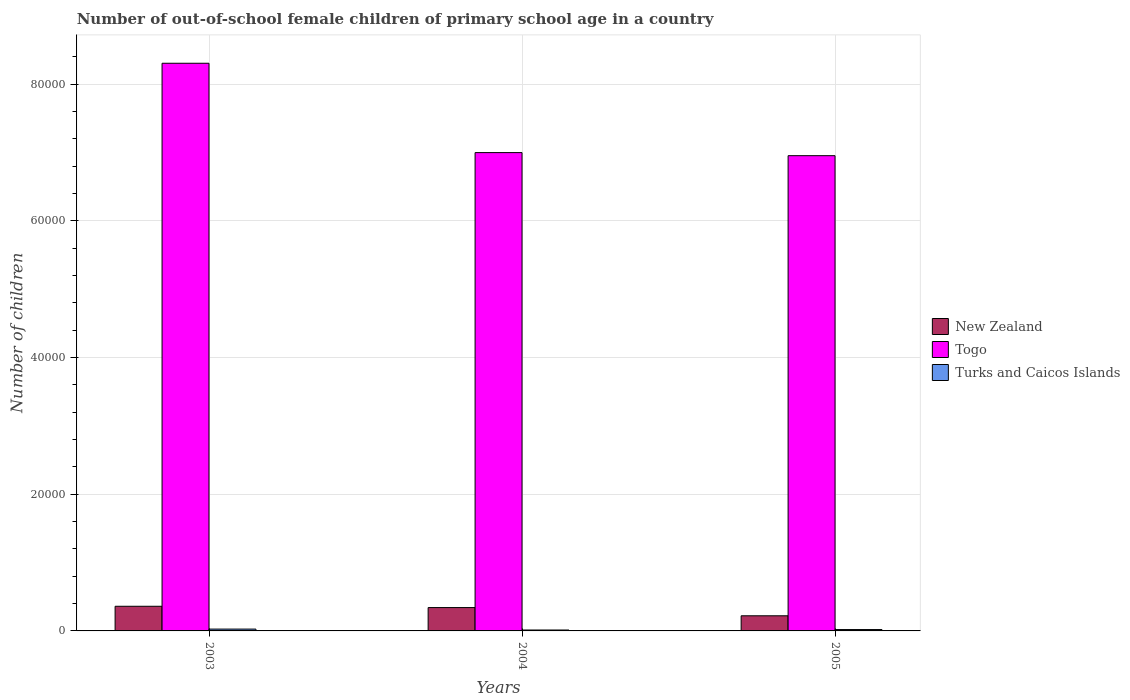How many bars are there on the 3rd tick from the right?
Your answer should be very brief. 3. What is the label of the 3rd group of bars from the left?
Offer a very short reply. 2005. What is the number of out-of-school female children in New Zealand in 2004?
Your answer should be very brief. 3417. Across all years, what is the maximum number of out-of-school female children in Turks and Caicos Islands?
Give a very brief answer. 268. Across all years, what is the minimum number of out-of-school female children in Turks and Caicos Islands?
Keep it short and to the point. 134. In which year was the number of out-of-school female children in Togo maximum?
Ensure brevity in your answer.  2003. What is the total number of out-of-school female children in Turks and Caicos Islands in the graph?
Your response must be concise. 601. What is the difference between the number of out-of-school female children in New Zealand in 2003 and that in 2005?
Make the answer very short. 1393. What is the difference between the number of out-of-school female children in Turks and Caicos Islands in 2005 and the number of out-of-school female children in Togo in 2004?
Your answer should be compact. -6.98e+04. What is the average number of out-of-school female children in Togo per year?
Ensure brevity in your answer.  7.42e+04. In the year 2004, what is the difference between the number of out-of-school female children in New Zealand and number of out-of-school female children in Turks and Caicos Islands?
Ensure brevity in your answer.  3283. What is the ratio of the number of out-of-school female children in New Zealand in 2003 to that in 2005?
Offer a very short reply. 1.63. What is the difference between the highest and the second highest number of out-of-school female children in Togo?
Offer a very short reply. 1.31e+04. What is the difference between the highest and the lowest number of out-of-school female children in New Zealand?
Ensure brevity in your answer.  1393. Is the sum of the number of out-of-school female children in New Zealand in 2004 and 2005 greater than the maximum number of out-of-school female children in Togo across all years?
Provide a short and direct response. No. What does the 3rd bar from the left in 2004 represents?
Your answer should be very brief. Turks and Caicos Islands. What does the 1st bar from the right in 2004 represents?
Offer a very short reply. Turks and Caicos Islands. Is it the case that in every year, the sum of the number of out-of-school female children in Turks and Caicos Islands and number of out-of-school female children in New Zealand is greater than the number of out-of-school female children in Togo?
Give a very brief answer. No. Are the values on the major ticks of Y-axis written in scientific E-notation?
Your response must be concise. No. How many legend labels are there?
Your answer should be compact. 3. How are the legend labels stacked?
Offer a terse response. Vertical. What is the title of the graph?
Keep it short and to the point. Number of out-of-school female children of primary school age in a country. What is the label or title of the X-axis?
Make the answer very short. Years. What is the label or title of the Y-axis?
Provide a short and direct response. Number of children. What is the Number of children in New Zealand in 2003?
Offer a terse response. 3607. What is the Number of children in Togo in 2003?
Keep it short and to the point. 8.31e+04. What is the Number of children of Turks and Caicos Islands in 2003?
Give a very brief answer. 268. What is the Number of children in New Zealand in 2004?
Keep it short and to the point. 3417. What is the Number of children of Togo in 2004?
Your response must be concise. 7.00e+04. What is the Number of children in Turks and Caicos Islands in 2004?
Your response must be concise. 134. What is the Number of children in New Zealand in 2005?
Your answer should be compact. 2214. What is the Number of children of Togo in 2005?
Your answer should be very brief. 6.95e+04. What is the Number of children in Turks and Caicos Islands in 2005?
Your response must be concise. 199. Across all years, what is the maximum Number of children of New Zealand?
Your response must be concise. 3607. Across all years, what is the maximum Number of children in Togo?
Provide a succinct answer. 8.31e+04. Across all years, what is the maximum Number of children in Turks and Caicos Islands?
Provide a short and direct response. 268. Across all years, what is the minimum Number of children in New Zealand?
Provide a short and direct response. 2214. Across all years, what is the minimum Number of children of Togo?
Keep it short and to the point. 6.95e+04. Across all years, what is the minimum Number of children in Turks and Caicos Islands?
Your response must be concise. 134. What is the total Number of children of New Zealand in the graph?
Give a very brief answer. 9238. What is the total Number of children of Togo in the graph?
Provide a succinct answer. 2.23e+05. What is the total Number of children in Turks and Caicos Islands in the graph?
Make the answer very short. 601. What is the difference between the Number of children in New Zealand in 2003 and that in 2004?
Your response must be concise. 190. What is the difference between the Number of children of Togo in 2003 and that in 2004?
Give a very brief answer. 1.31e+04. What is the difference between the Number of children in Turks and Caicos Islands in 2003 and that in 2004?
Give a very brief answer. 134. What is the difference between the Number of children in New Zealand in 2003 and that in 2005?
Offer a terse response. 1393. What is the difference between the Number of children of Togo in 2003 and that in 2005?
Provide a short and direct response. 1.35e+04. What is the difference between the Number of children of New Zealand in 2004 and that in 2005?
Give a very brief answer. 1203. What is the difference between the Number of children of Togo in 2004 and that in 2005?
Offer a terse response. 450. What is the difference between the Number of children of Turks and Caicos Islands in 2004 and that in 2005?
Your answer should be very brief. -65. What is the difference between the Number of children of New Zealand in 2003 and the Number of children of Togo in 2004?
Your answer should be very brief. -6.64e+04. What is the difference between the Number of children in New Zealand in 2003 and the Number of children in Turks and Caicos Islands in 2004?
Your answer should be compact. 3473. What is the difference between the Number of children in Togo in 2003 and the Number of children in Turks and Caicos Islands in 2004?
Keep it short and to the point. 8.29e+04. What is the difference between the Number of children in New Zealand in 2003 and the Number of children in Togo in 2005?
Offer a very short reply. -6.59e+04. What is the difference between the Number of children of New Zealand in 2003 and the Number of children of Turks and Caicos Islands in 2005?
Your answer should be very brief. 3408. What is the difference between the Number of children in Togo in 2003 and the Number of children in Turks and Caicos Islands in 2005?
Your answer should be compact. 8.29e+04. What is the difference between the Number of children of New Zealand in 2004 and the Number of children of Togo in 2005?
Provide a short and direct response. -6.61e+04. What is the difference between the Number of children in New Zealand in 2004 and the Number of children in Turks and Caicos Islands in 2005?
Give a very brief answer. 3218. What is the difference between the Number of children of Togo in 2004 and the Number of children of Turks and Caicos Islands in 2005?
Your answer should be very brief. 6.98e+04. What is the average Number of children of New Zealand per year?
Your answer should be very brief. 3079.33. What is the average Number of children of Togo per year?
Make the answer very short. 7.42e+04. What is the average Number of children of Turks and Caicos Islands per year?
Offer a terse response. 200.33. In the year 2003, what is the difference between the Number of children in New Zealand and Number of children in Togo?
Ensure brevity in your answer.  -7.95e+04. In the year 2003, what is the difference between the Number of children of New Zealand and Number of children of Turks and Caicos Islands?
Keep it short and to the point. 3339. In the year 2003, what is the difference between the Number of children in Togo and Number of children in Turks and Caicos Islands?
Your answer should be very brief. 8.28e+04. In the year 2004, what is the difference between the Number of children in New Zealand and Number of children in Togo?
Give a very brief answer. -6.66e+04. In the year 2004, what is the difference between the Number of children of New Zealand and Number of children of Turks and Caicos Islands?
Your answer should be very brief. 3283. In the year 2004, what is the difference between the Number of children of Togo and Number of children of Turks and Caicos Islands?
Offer a terse response. 6.99e+04. In the year 2005, what is the difference between the Number of children in New Zealand and Number of children in Togo?
Your answer should be very brief. -6.73e+04. In the year 2005, what is the difference between the Number of children in New Zealand and Number of children in Turks and Caicos Islands?
Provide a short and direct response. 2015. In the year 2005, what is the difference between the Number of children of Togo and Number of children of Turks and Caicos Islands?
Your response must be concise. 6.93e+04. What is the ratio of the Number of children in New Zealand in 2003 to that in 2004?
Ensure brevity in your answer.  1.06. What is the ratio of the Number of children in Togo in 2003 to that in 2004?
Your answer should be compact. 1.19. What is the ratio of the Number of children of New Zealand in 2003 to that in 2005?
Provide a succinct answer. 1.63. What is the ratio of the Number of children in Togo in 2003 to that in 2005?
Offer a very short reply. 1.19. What is the ratio of the Number of children in Turks and Caicos Islands in 2003 to that in 2005?
Make the answer very short. 1.35. What is the ratio of the Number of children in New Zealand in 2004 to that in 2005?
Provide a succinct answer. 1.54. What is the ratio of the Number of children of Turks and Caicos Islands in 2004 to that in 2005?
Offer a very short reply. 0.67. What is the difference between the highest and the second highest Number of children in New Zealand?
Your response must be concise. 190. What is the difference between the highest and the second highest Number of children in Togo?
Your answer should be compact. 1.31e+04. What is the difference between the highest and the lowest Number of children of New Zealand?
Make the answer very short. 1393. What is the difference between the highest and the lowest Number of children of Togo?
Your answer should be very brief. 1.35e+04. What is the difference between the highest and the lowest Number of children in Turks and Caicos Islands?
Keep it short and to the point. 134. 